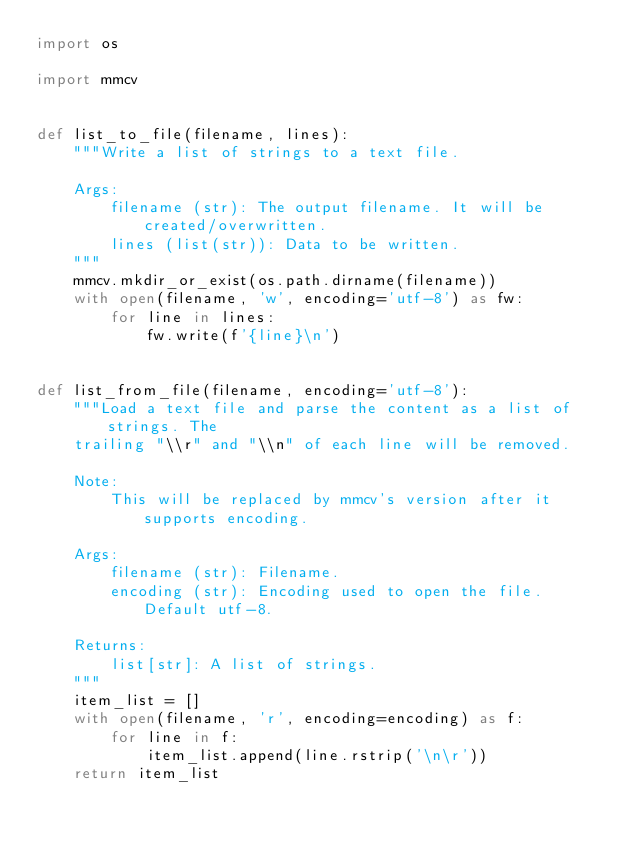<code> <loc_0><loc_0><loc_500><loc_500><_Python_>import os

import mmcv


def list_to_file(filename, lines):
    """Write a list of strings to a text file.

    Args:
        filename (str): The output filename. It will be created/overwritten.
        lines (list(str)): Data to be written.
    """
    mmcv.mkdir_or_exist(os.path.dirname(filename))
    with open(filename, 'w', encoding='utf-8') as fw:
        for line in lines:
            fw.write(f'{line}\n')


def list_from_file(filename, encoding='utf-8'):
    """Load a text file and parse the content as a list of strings. The
    trailing "\\r" and "\\n" of each line will be removed.

    Note:
        This will be replaced by mmcv's version after it supports encoding.

    Args:
        filename (str): Filename.
        encoding (str): Encoding used to open the file. Default utf-8.

    Returns:
        list[str]: A list of strings.
    """
    item_list = []
    with open(filename, 'r', encoding=encoding) as f:
        for line in f:
            item_list.append(line.rstrip('\n\r'))
    return item_list
</code> 